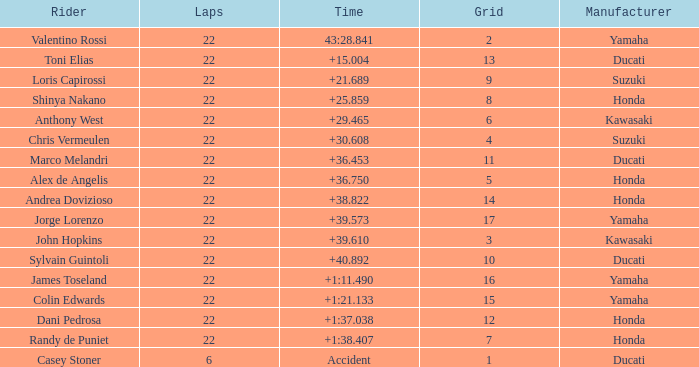What grid is Ducati with fewer than 22 laps? 1.0. 